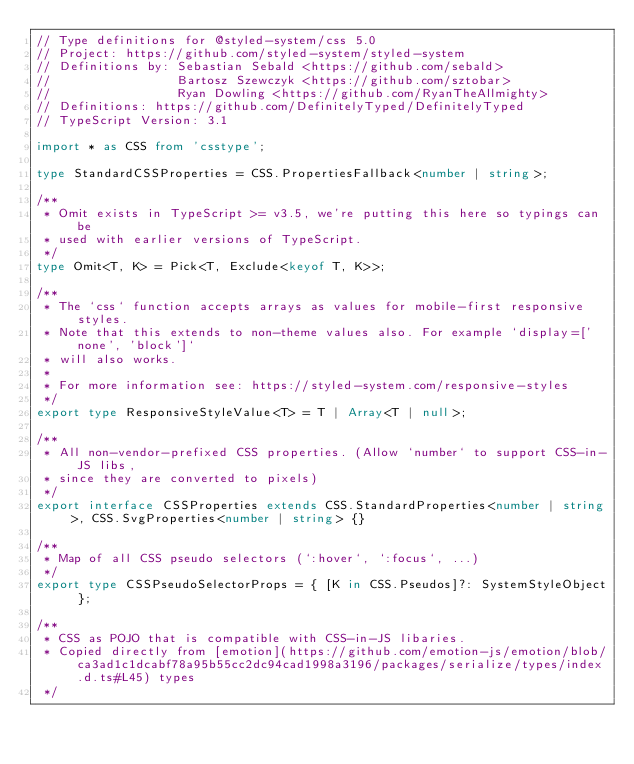<code> <loc_0><loc_0><loc_500><loc_500><_TypeScript_>// Type definitions for @styled-system/css 5.0
// Project: https://github.com/styled-system/styled-system
// Definitions by: Sebastian Sebald <https://github.com/sebald>
//                 Bartosz Szewczyk <https://github.com/sztobar>
//                 Ryan Dowling <https://github.com/RyanTheAllmighty>
// Definitions: https://github.com/DefinitelyTyped/DefinitelyTyped
// TypeScript Version: 3.1

import * as CSS from 'csstype';

type StandardCSSProperties = CSS.PropertiesFallback<number | string>;

/**
 * Omit exists in TypeScript >= v3.5, we're putting this here so typings can be
 * used with earlier versions of TypeScript.
 */
type Omit<T, K> = Pick<T, Exclude<keyof T, K>>;

/**
 * The `css` function accepts arrays as values for mobile-first responsive styles.
 * Note that this extends to non-theme values also. For example `display=['none', 'block']`
 * will also works.
 *
 * For more information see: https://styled-system.com/responsive-styles
 */
export type ResponsiveStyleValue<T> = T | Array<T | null>;

/**
 * All non-vendor-prefixed CSS properties. (Allow `number` to support CSS-in-JS libs,
 * since they are converted to pixels)
 */
export interface CSSProperties extends CSS.StandardProperties<number | string>, CSS.SvgProperties<number | string> {}

/**
 * Map of all CSS pseudo selectors (`:hover`, `:focus`, ...)
 */
export type CSSPseudoSelectorProps = { [K in CSS.Pseudos]?: SystemStyleObject };

/**
 * CSS as POJO that is compatible with CSS-in-JS libaries.
 * Copied directly from [emotion](https://github.com/emotion-js/emotion/blob/ca3ad1c1dcabf78a95b55cc2dc94cad1998a3196/packages/serialize/types/index.d.ts#L45) types
 */</code> 